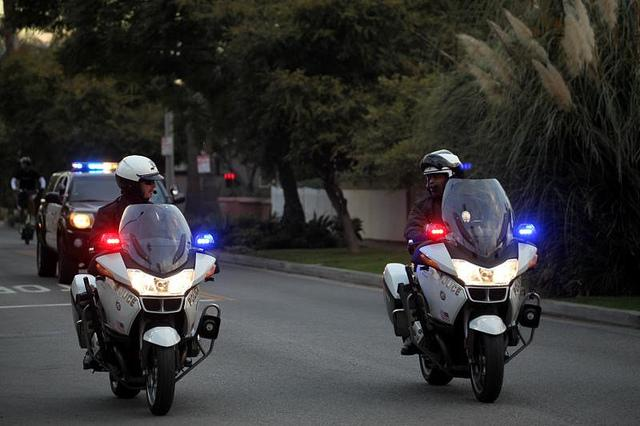What color is the officer riding on the police motorcycle to the left? Please explain your reasoning. white. His skin color is pale normally people who are pale are of european descent. 